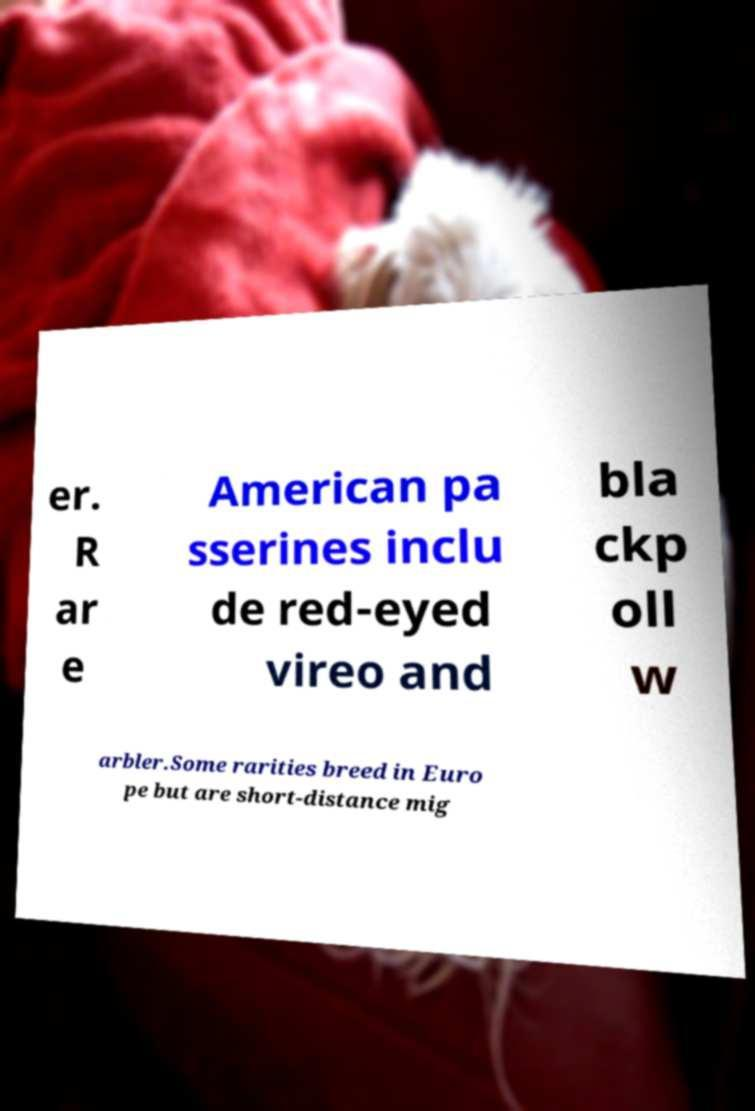What messages or text are displayed in this image? I need them in a readable, typed format. er. R ar e American pa sserines inclu de red-eyed vireo and bla ckp oll w arbler.Some rarities breed in Euro pe but are short-distance mig 